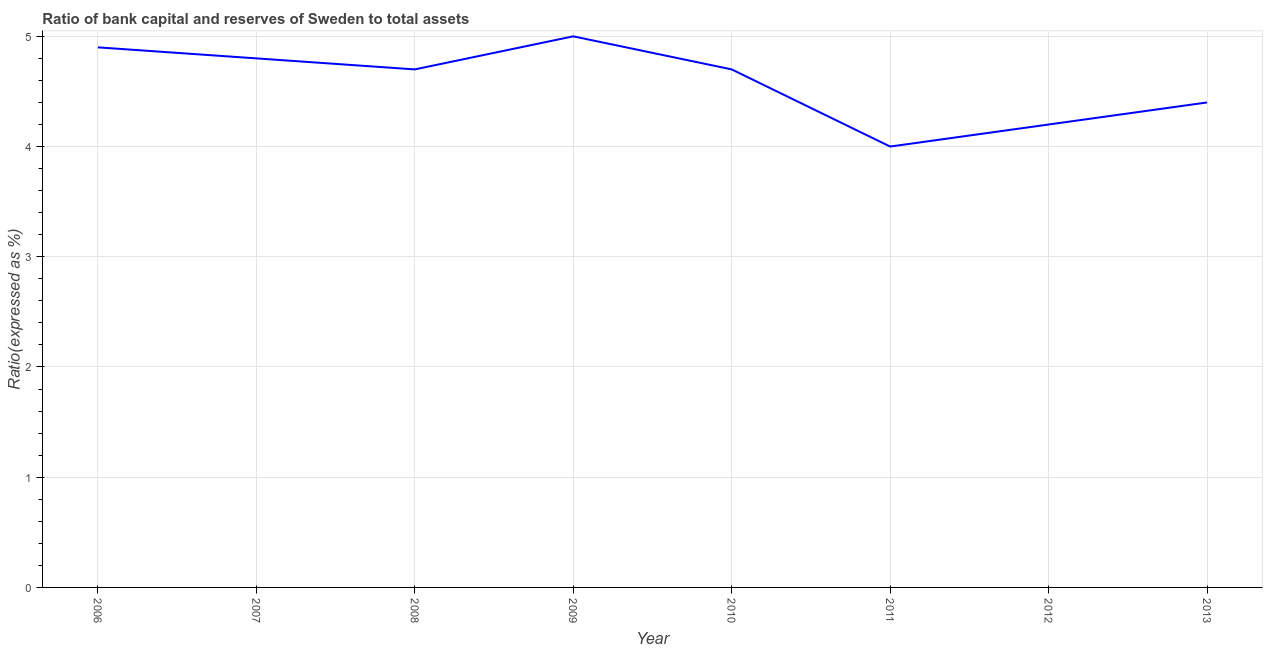Across all years, what is the maximum bank capital to assets ratio?
Offer a terse response. 5. Across all years, what is the minimum bank capital to assets ratio?
Offer a terse response. 4. In which year was the bank capital to assets ratio maximum?
Offer a terse response. 2009. What is the sum of the bank capital to assets ratio?
Offer a very short reply. 36.7. What is the difference between the bank capital to assets ratio in 2007 and 2009?
Your response must be concise. -0.2. What is the average bank capital to assets ratio per year?
Make the answer very short. 4.59. Do a majority of the years between 2012 and 2008 (inclusive) have bank capital to assets ratio greater than 1.6 %?
Offer a very short reply. Yes. What is the ratio of the bank capital to assets ratio in 2007 to that in 2008?
Give a very brief answer. 1.02. What is the difference between the highest and the second highest bank capital to assets ratio?
Offer a very short reply. 0.1. Does the bank capital to assets ratio monotonically increase over the years?
Your response must be concise. No. Are the values on the major ticks of Y-axis written in scientific E-notation?
Offer a terse response. No. Does the graph contain any zero values?
Provide a succinct answer. No. Does the graph contain grids?
Provide a succinct answer. Yes. What is the title of the graph?
Provide a short and direct response. Ratio of bank capital and reserves of Sweden to total assets. What is the label or title of the X-axis?
Offer a terse response. Year. What is the label or title of the Y-axis?
Offer a very short reply. Ratio(expressed as %). What is the Ratio(expressed as %) of 2006?
Your answer should be very brief. 4.9. What is the Ratio(expressed as %) in 2008?
Provide a succinct answer. 4.7. What is the Ratio(expressed as %) of 2011?
Give a very brief answer. 4. What is the Ratio(expressed as %) in 2012?
Provide a succinct answer. 4.2. What is the Ratio(expressed as %) of 2013?
Offer a very short reply. 4.4. What is the difference between the Ratio(expressed as %) in 2006 and 2007?
Your answer should be compact. 0.1. What is the difference between the Ratio(expressed as %) in 2006 and 2008?
Offer a terse response. 0.2. What is the difference between the Ratio(expressed as %) in 2006 and 2013?
Ensure brevity in your answer.  0.5. What is the difference between the Ratio(expressed as %) in 2008 and 2011?
Ensure brevity in your answer.  0.7. What is the difference between the Ratio(expressed as %) in 2008 and 2012?
Provide a succinct answer. 0.5. What is the difference between the Ratio(expressed as %) in 2008 and 2013?
Offer a very short reply. 0.3. What is the difference between the Ratio(expressed as %) in 2009 and 2010?
Your answer should be very brief. 0.3. What is the difference between the Ratio(expressed as %) in 2009 and 2012?
Make the answer very short. 0.8. What is the difference between the Ratio(expressed as %) in 2010 and 2012?
Provide a short and direct response. 0.5. What is the difference between the Ratio(expressed as %) in 2011 and 2012?
Offer a terse response. -0.2. What is the difference between the Ratio(expressed as %) in 2011 and 2013?
Ensure brevity in your answer.  -0.4. What is the difference between the Ratio(expressed as %) in 2012 and 2013?
Keep it short and to the point. -0.2. What is the ratio of the Ratio(expressed as %) in 2006 to that in 2007?
Provide a short and direct response. 1.02. What is the ratio of the Ratio(expressed as %) in 2006 to that in 2008?
Your answer should be compact. 1.04. What is the ratio of the Ratio(expressed as %) in 2006 to that in 2009?
Your response must be concise. 0.98. What is the ratio of the Ratio(expressed as %) in 2006 to that in 2010?
Offer a very short reply. 1.04. What is the ratio of the Ratio(expressed as %) in 2006 to that in 2011?
Your response must be concise. 1.23. What is the ratio of the Ratio(expressed as %) in 2006 to that in 2012?
Offer a terse response. 1.17. What is the ratio of the Ratio(expressed as %) in 2006 to that in 2013?
Offer a terse response. 1.11. What is the ratio of the Ratio(expressed as %) in 2007 to that in 2008?
Provide a succinct answer. 1.02. What is the ratio of the Ratio(expressed as %) in 2007 to that in 2009?
Keep it short and to the point. 0.96. What is the ratio of the Ratio(expressed as %) in 2007 to that in 2011?
Keep it short and to the point. 1.2. What is the ratio of the Ratio(expressed as %) in 2007 to that in 2012?
Make the answer very short. 1.14. What is the ratio of the Ratio(expressed as %) in 2007 to that in 2013?
Provide a short and direct response. 1.09. What is the ratio of the Ratio(expressed as %) in 2008 to that in 2009?
Offer a terse response. 0.94. What is the ratio of the Ratio(expressed as %) in 2008 to that in 2011?
Make the answer very short. 1.18. What is the ratio of the Ratio(expressed as %) in 2008 to that in 2012?
Offer a very short reply. 1.12. What is the ratio of the Ratio(expressed as %) in 2008 to that in 2013?
Provide a succinct answer. 1.07. What is the ratio of the Ratio(expressed as %) in 2009 to that in 2010?
Give a very brief answer. 1.06. What is the ratio of the Ratio(expressed as %) in 2009 to that in 2011?
Provide a short and direct response. 1.25. What is the ratio of the Ratio(expressed as %) in 2009 to that in 2012?
Your answer should be compact. 1.19. What is the ratio of the Ratio(expressed as %) in 2009 to that in 2013?
Your answer should be compact. 1.14. What is the ratio of the Ratio(expressed as %) in 2010 to that in 2011?
Make the answer very short. 1.18. What is the ratio of the Ratio(expressed as %) in 2010 to that in 2012?
Your answer should be very brief. 1.12. What is the ratio of the Ratio(expressed as %) in 2010 to that in 2013?
Offer a very short reply. 1.07. What is the ratio of the Ratio(expressed as %) in 2011 to that in 2013?
Your answer should be very brief. 0.91. What is the ratio of the Ratio(expressed as %) in 2012 to that in 2013?
Provide a short and direct response. 0.95. 